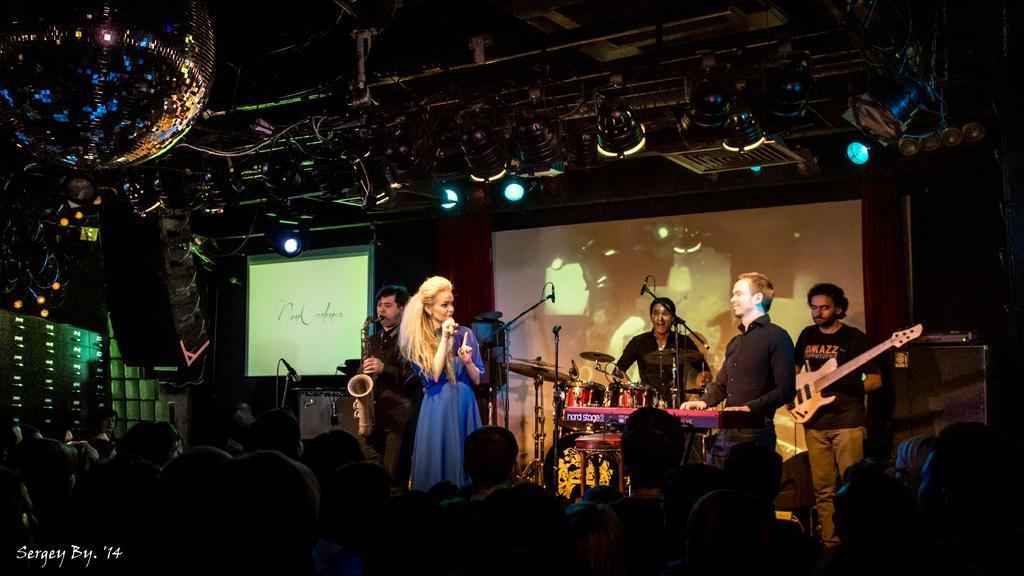Can you describe this image briefly? Here I can see a woman and a few men are standing on the stage. The woman is holding a mike in the hand and the men are playing some musical instruments. In the background there are two screens. On the top I can see the lights. At the bottom of the image I can see few people are looking at the stage. 